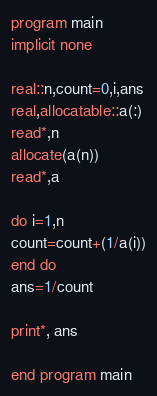<code> <loc_0><loc_0><loc_500><loc_500><_FORTRAN_>program main
implicit none

real::n,count=0,i,ans
real,allocatable::a(:)
read*,n
allocate(a(n))
read*,a

do i=1,n
count=count+(1/a(i))
end do
ans=1/count

print*, ans

end program main</code> 